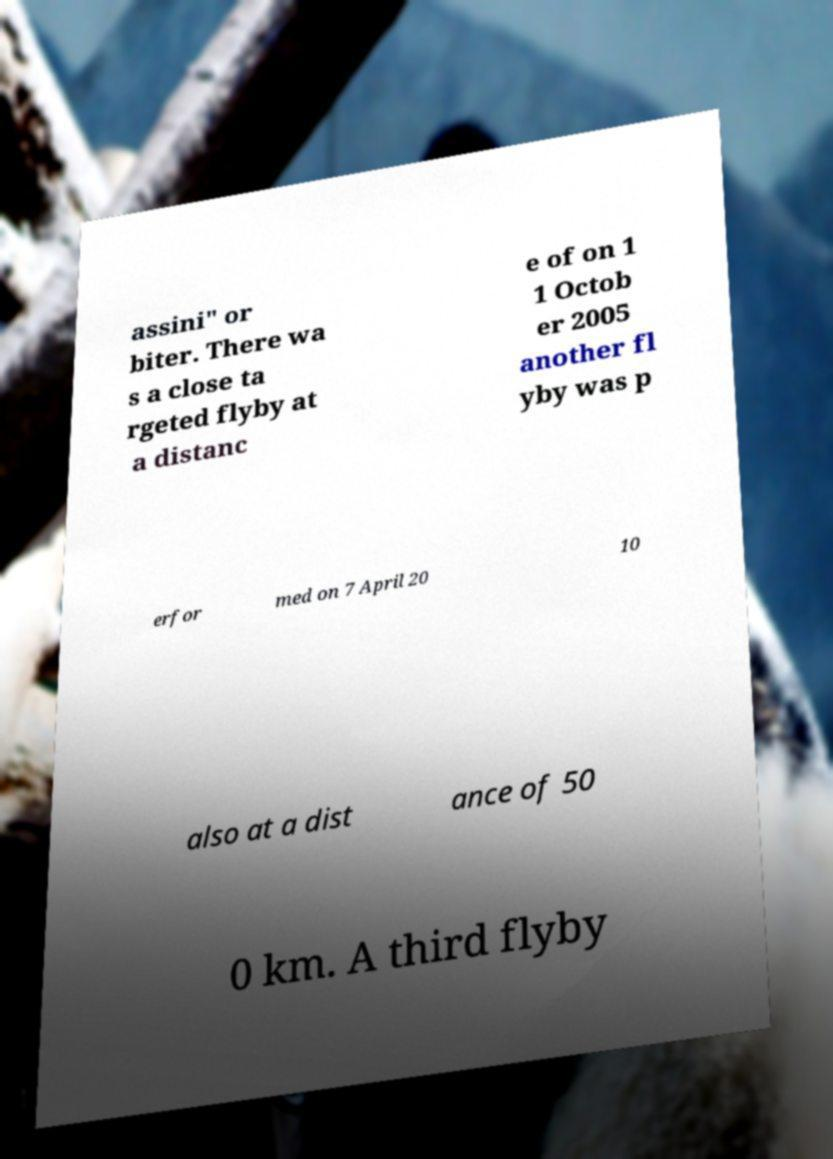Can you read and provide the text displayed in the image?This photo seems to have some interesting text. Can you extract and type it out for me? assini" or biter. There wa s a close ta rgeted flyby at a distanc e of on 1 1 Octob er 2005 another fl yby was p erfor med on 7 April 20 10 also at a dist ance of 50 0 km. A third flyby 